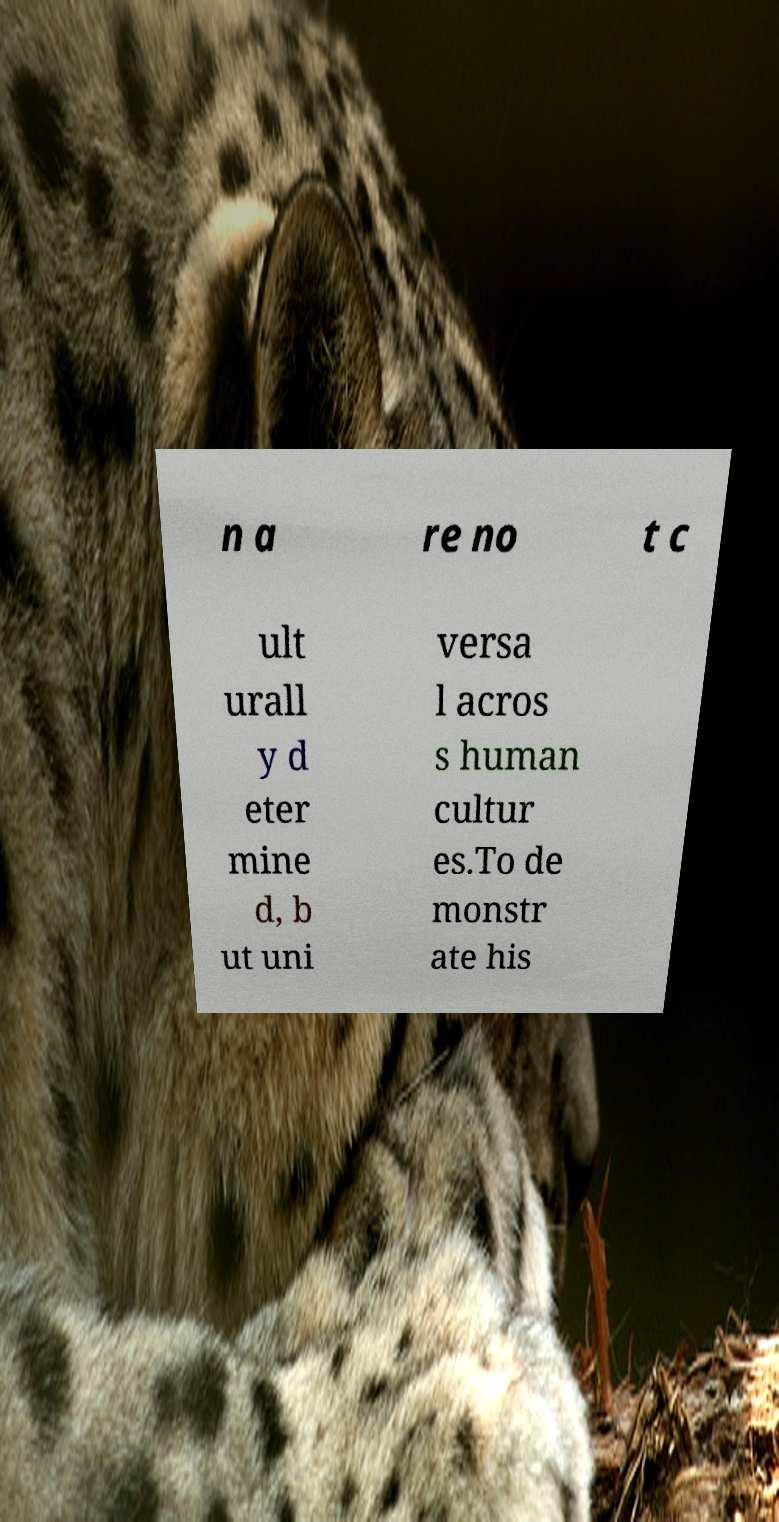Please identify and transcribe the text found in this image. n a re no t c ult urall y d eter mine d, b ut uni versa l acros s human cultur es.To de monstr ate his 